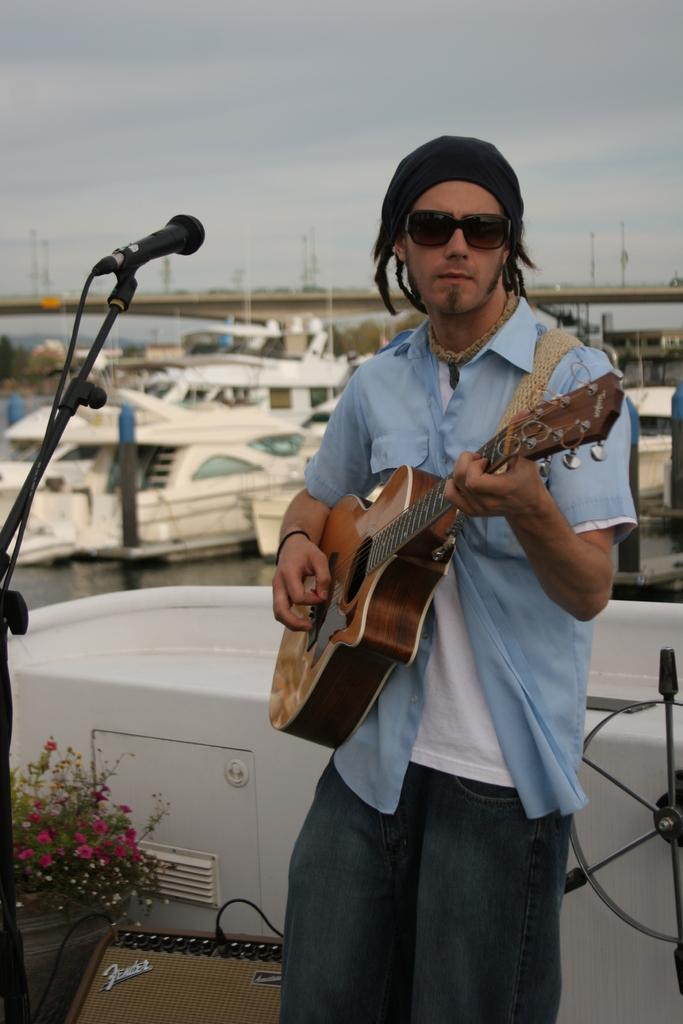What can be seen in the sky in the image? The sky is visible in the image, but no specific details are provided. What type of structure is present in the image? There is a bridge in the image. What type of vehicles are in the image? There are boats in the image. What is the man holding in the image? The man is holding a guitar in the image. What object is used for amplifying sound in the image? There is a microphone in the image. What type of jeans is the man wearing in the image? There is no information about the man's clothing in the image, so we cannot determine if he is wearing jeans or any other type of clothing. What type of alarm system is installed in the bridge in the image? There is no mention of an alarm system in the image, so we cannot determine if one is installed or not. 